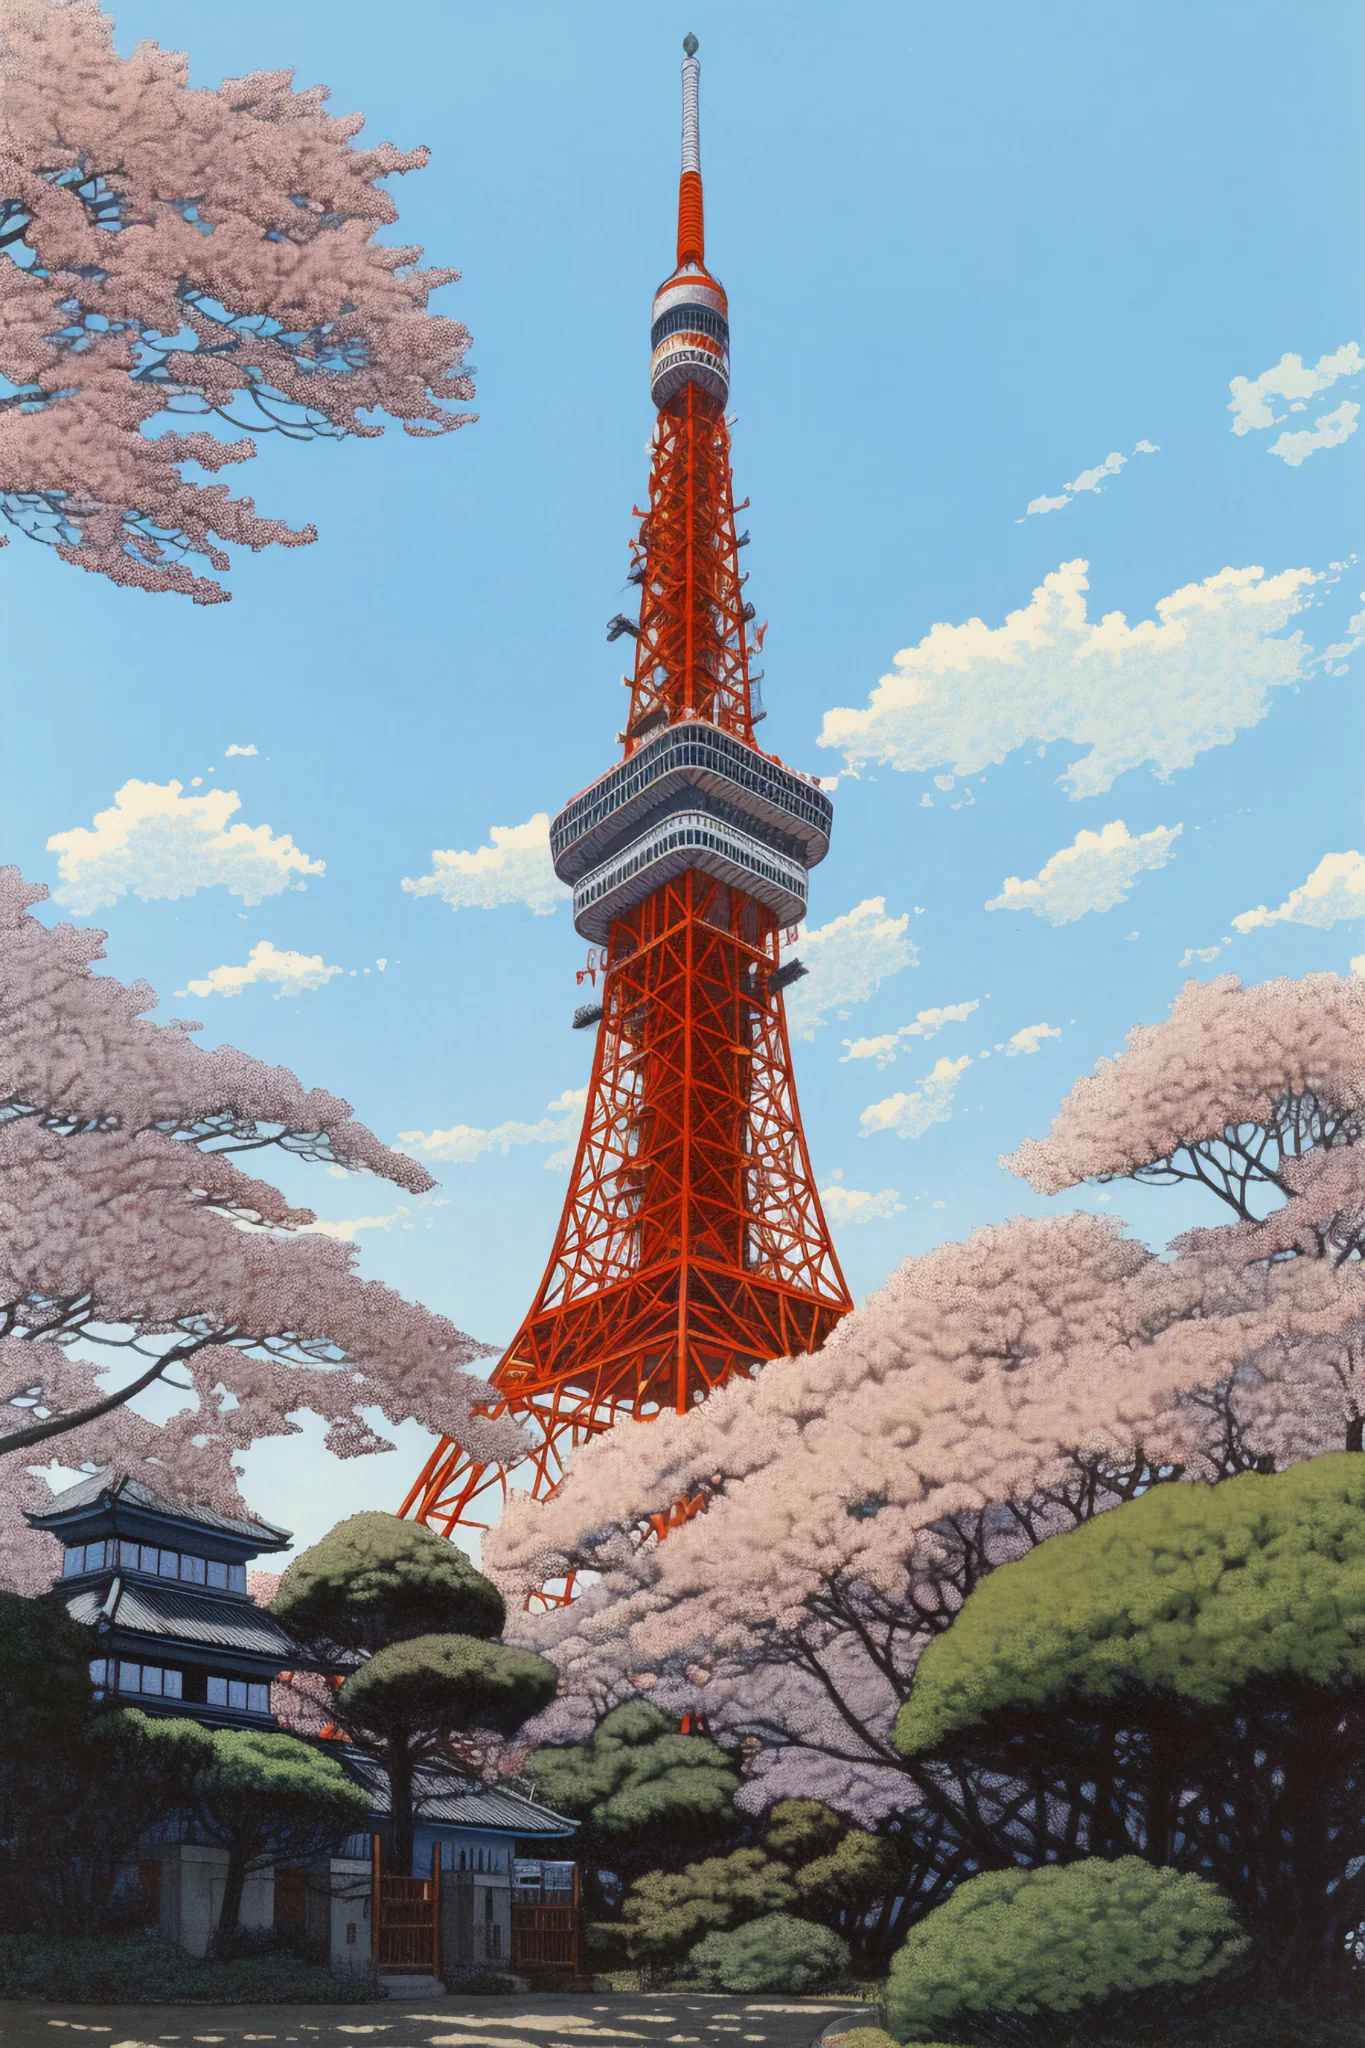What are the key elements in this picture? This image prominently features the Tokyo Tower, an architectural homage to both modern influence and traditional Japanese culture, distinguished by its vivid orange hue. The tower rises imposingly against a backdrop of clear blue sky, observed from a lower viewpoint that emphasizes its grandeur. Surrounding the tower's base, a flourish of cherry blossoms adds a delicate contrast with their rich pink canopies, symbolizing the beauty and transience of life which is celebrated during the annual Hanami festival. These blossoms, along with neatly trimmed green shrubbery and a traditionally styled Japanese building, provide a serene and culturally rich foreground, presenting a harmonious blend of urban and natural elements in the heart of Tokyo. 